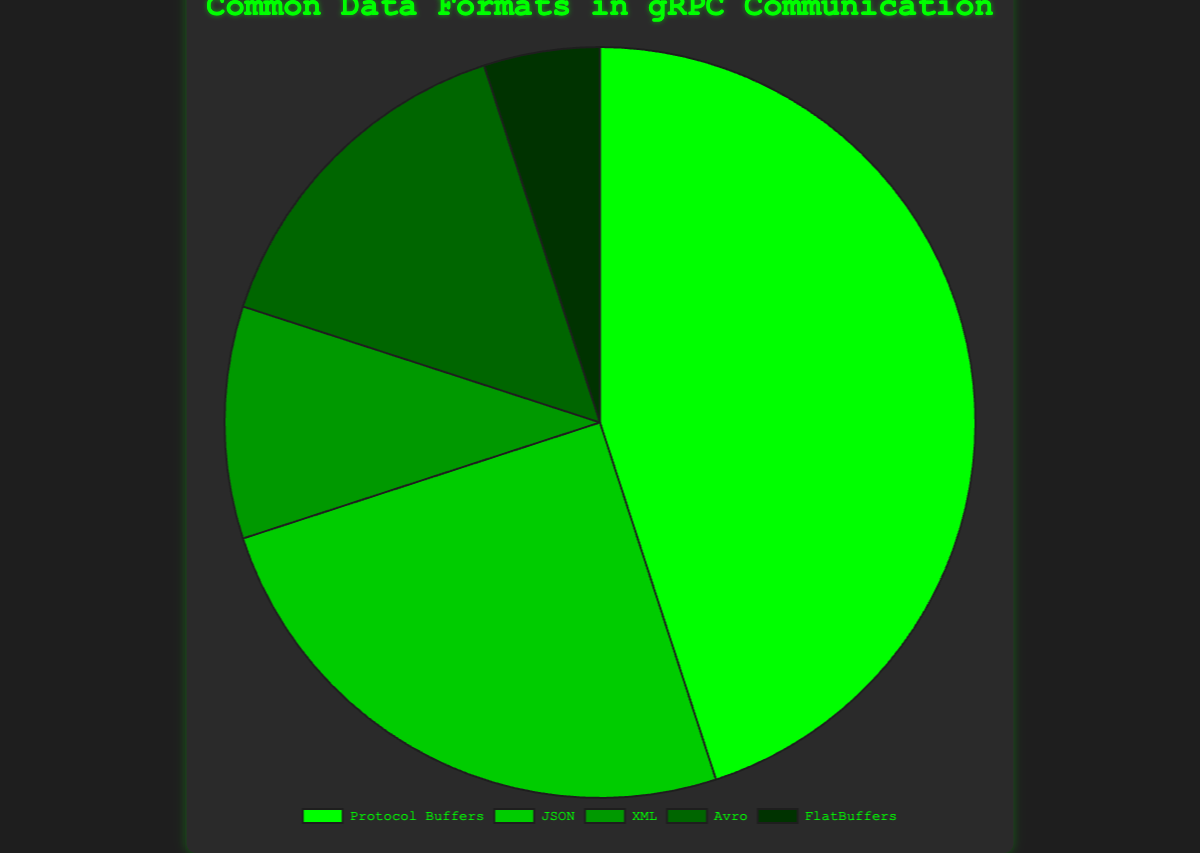Which data format has the highest usage percentage? The chart shows different data formats used in gRPC communication with their corresponding usage percentages. From the chart, Protocol Buffers has the largest segment.
Answer: Protocol Buffers How much greater is the usage percentage of Protocol Buffers compared to FlatBuffers? The usage percentage of Protocol Buffers is 45%, and FlatBuffers is 5%. The difference can be found by subtracting 5% from 45%.
Answer: 40% Which two data formats have a combined usage percentage equal to that of Protocol Buffers? From the chart, JSON has 25%, and Avro has 15%. Adding them together (25% + 15%) equals 40%. Checking another pair, JSON (25%) + XML (10%) is 35%. Avro (15%) + XML (10%) is 25%. FlatBuffers (5%) + Avro (15%) is 20%. No combination matches 45%, showing no exact match.
Answer: None found What is the least used data format and its percentage? Observing the chart segments, FlatBuffers occupies the smallest portion. The label associated with FlatBuffers is 5%.
Answer: FlatBuffers, 5% What percentage of the usage is represented by non-Protocol Buffers formats combined? Summing the percentages of JSON (25%), XML (10%), Avro (15%), and FlatBuffers (5%) results in 25% + 10% + 15% + 5%. Adding them together gives 55%.
Answer: 55% How does the usage percentage of JSON compare to that of XML? The chart shows JSON with a 25% usage percentage and XML with a 10% usage percentage. By comparing the two, 25% is greater than 10%.
Answer: JSON is greater Between Avro and FlatBuffers, which format is used less frequently, and by how much? Avro has a usage percentage of 15%, whereas FlatBuffers has 5%. Finding the difference, 15% - 5%, results in 10%. Thus, FlatBuffers is used less frequently by 10%.
Answer: FlatBuffers, 10% What is the total percentage usage of the three least common data formats? The three least common data formats are XML (10%), Avro (15%), and FlatBuffers (5%). Summing these: 10% + 15% + 5% = 30%.
Answer: 30% What is the ratio of the usage percentages of Protocol Buffers to JSON? The usage percentage for Protocol Buffers is 45% and for JSON is 25%. The ratio is calculated by dividing 45 by 25, which simplifies to 9/5 or 1.8.
Answer: 1.8 Which color represents Avro in the chart? Avro in the chart is represented by the fourth color segment from the legend, which is likely a dark green hue.
Answer: Dark Green 